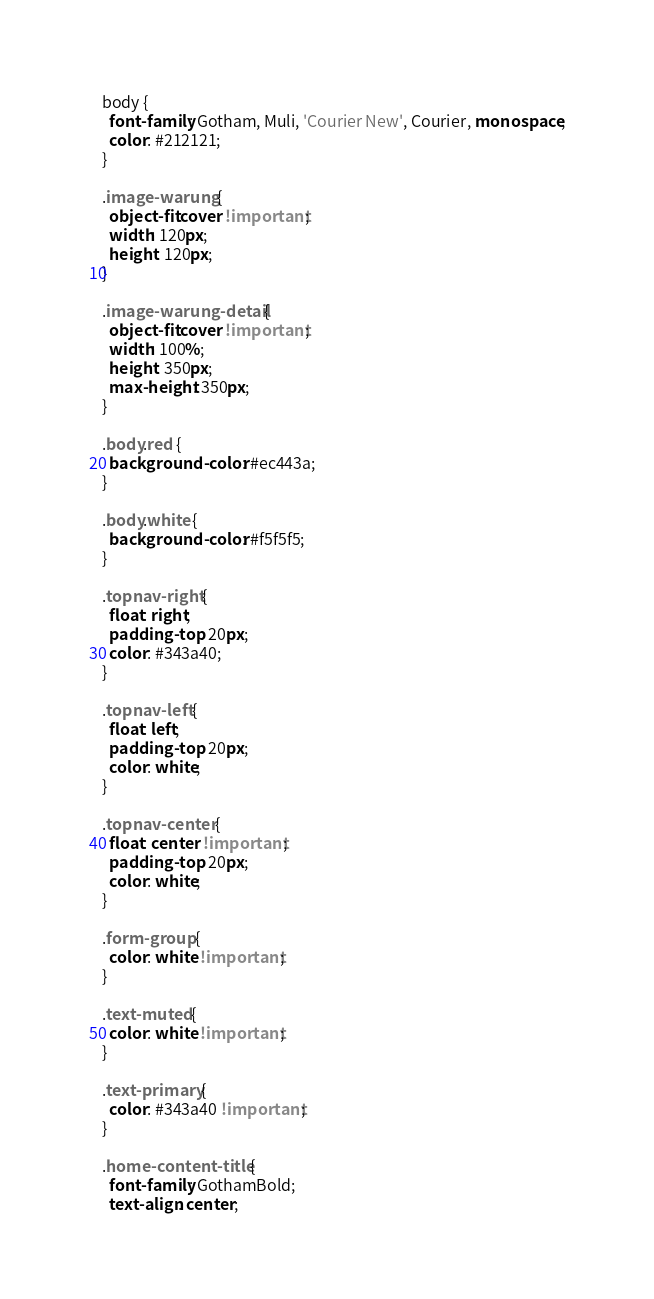<code> <loc_0><loc_0><loc_500><loc_500><_CSS_>body {
  font-family: Gotham, Muli, 'Courier New', Courier, monospace;
  color: #212121;
}

.image-warung {
  object-fit:cover !important;
  width: 120px;
  height: 120px;
}

.image-warung-detail {
  object-fit:cover !important;
  width: 100%;
  height: 350px;
  max-height: 350px;
}

.body.red {
  background-color: #ec443a;
}

.body.white {
  background-color: #f5f5f5;
}

.topnav-right {
  float: right;
  padding-top: 20px;
  color: #343a40;
}

.topnav-left {
  float: left;
  padding-top: 20px;
  color: white;
}

.topnav-center {
  float: center !important;
  padding-top: 20px;
  color: white;
}

.form-group {
  color: white !important;
}

.text-muted {
  color: white !important;
}

.text-primary {
  color: #343a40 !important;
}

.home-content-title {
  font-family: GothamBold;
  text-align: center;</code> 